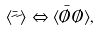<formula> <loc_0><loc_0><loc_500><loc_500>\langle \bar { \psi } \psi \rangle \Leftrightarrow \langle \bar { \chi } \chi \rangle ,</formula> 